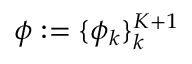<formula> <loc_0><loc_0><loc_500><loc_500>\phi \colon = \{ \phi _ { k } \} _ { k } ^ { K + 1 }</formula> 